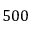Convert formula to latex. <formula><loc_0><loc_0><loc_500><loc_500>5 0 0</formula> 